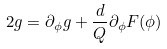<formula> <loc_0><loc_0><loc_500><loc_500>2 g = \partial _ { \phi } g + { \frac { d } { Q } } \partial _ { \phi } F ( \phi )</formula> 